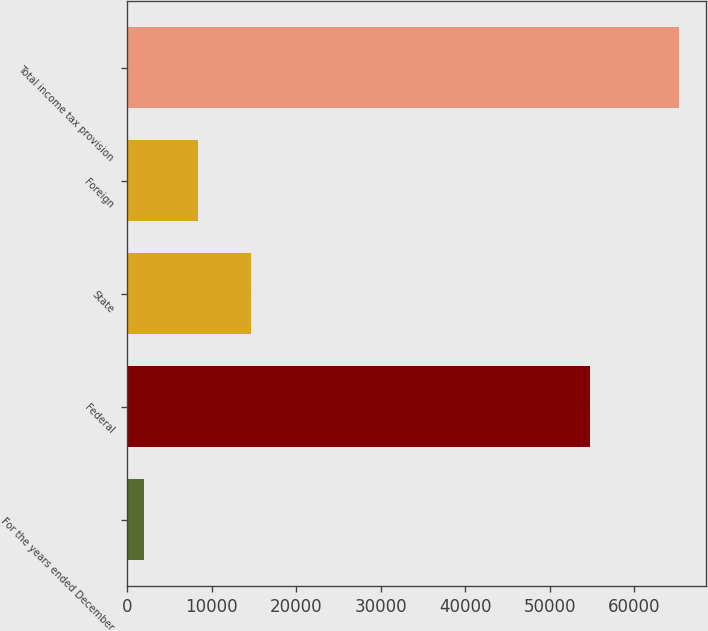Convert chart. <chart><loc_0><loc_0><loc_500><loc_500><bar_chart><fcel>For the years ended December<fcel>Federal<fcel>State<fcel>Foreign<fcel>Total income tax provision<nl><fcel>2012<fcel>54815<fcel>14671.6<fcel>8341.8<fcel>65310<nl></chart> 